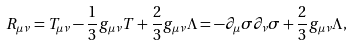Convert formula to latex. <formula><loc_0><loc_0><loc_500><loc_500>R _ { \mu \nu } = T _ { \mu \nu } - \frac { 1 } { 3 } g _ { \mu \nu } T + \frac { 2 } { 3 } g _ { \mu \nu } \Lambda = - \partial _ { \mu } \sigma \partial _ { \nu } \sigma + \frac { 2 } { 3 } g _ { \mu \nu } \Lambda ,</formula> 